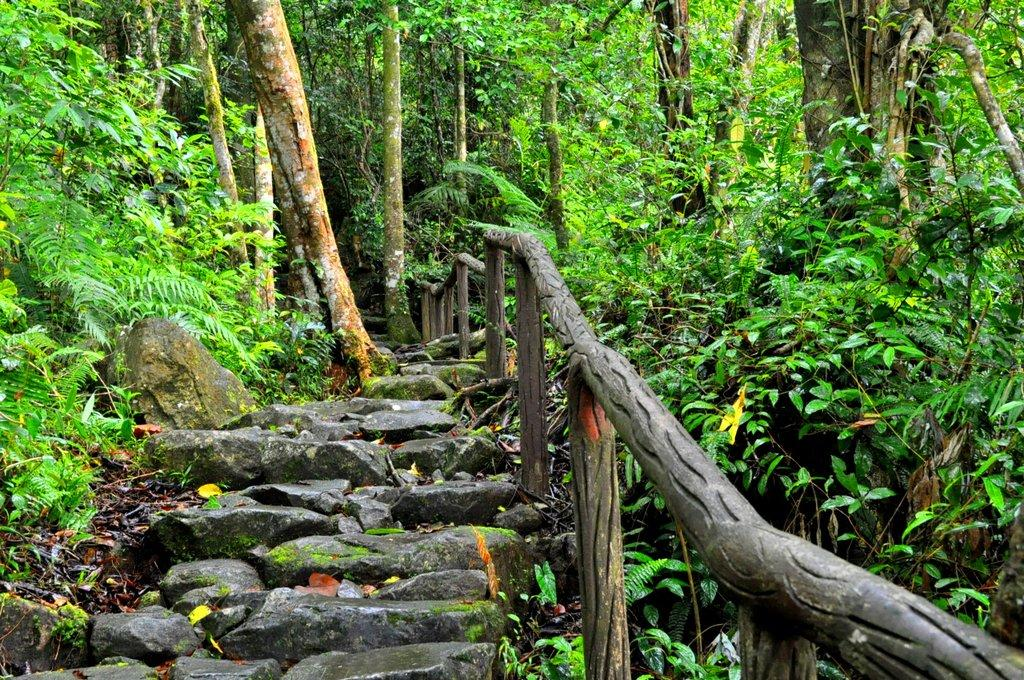What type of natural elements can be seen in the image? There are stones, plants, and trees in the image. What type of man-made structure is present in the image? There is a wooden fence in the image. What type of island is visible in the image? There is no island present in the image. What type of mass is being used to create the fence in the image? The fence in the image is made of wood, not mass. 